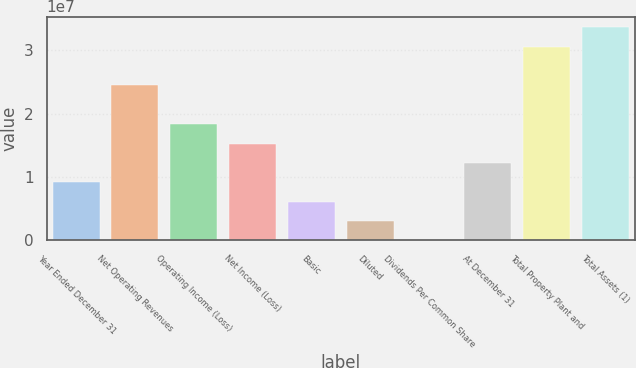<chart> <loc_0><loc_0><loc_500><loc_500><bar_chart><fcel>Year Ended December 31<fcel>Net Operating Revenues<fcel>Operating Income (Loss)<fcel>Net Income (Loss)<fcel>Basic<fcel>Diluted<fcel>Dividends Per Common Share<fcel>At December 31<fcel>Total Property Plant and<fcel>Total Assets (1)<nl><fcel>9.17105e+06<fcel>2.44561e+07<fcel>1.83421e+07<fcel>1.52851e+07<fcel>6.11404e+06<fcel>3.05702e+06<fcel>0.38<fcel>1.22281e+07<fcel>3.05702e+07<fcel>3.36272e+07<nl></chart> 